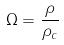Convert formula to latex. <formula><loc_0><loc_0><loc_500><loc_500>\Omega = \frac { \rho } { \rho _ { c } }</formula> 